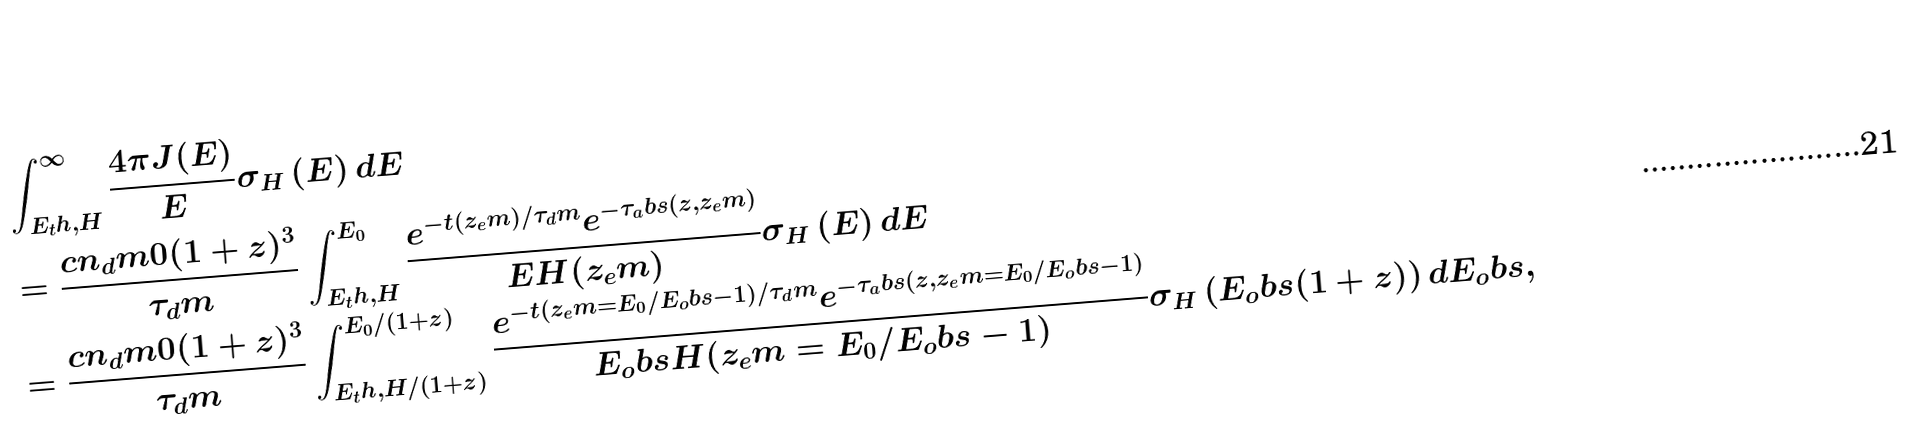<formula> <loc_0><loc_0><loc_500><loc_500>& \int ^ { \infty } _ { E _ { t } h , H } \frac { 4 \pi J ( E ) } { E } \sigma _ { H } \left ( E \right ) d E \\ & = \frac { c n _ { d } m 0 ( 1 + z ) ^ { 3 } } { \tau _ { d } m } \int ^ { E _ { 0 } } _ { E _ { t } h , H } \frac { e ^ { - t ( z _ { e } m ) / \tau _ { d } m } e ^ { - \tau _ { a } b s ( z , z _ { e } m ) } } { E H ( z _ { e } m ) } \sigma _ { H } \left ( E \right ) d E \\ & = \frac { c n _ { d } m 0 ( 1 + z ) ^ { 3 } } { \tau _ { d } m } \int ^ { E _ { 0 } / ( 1 + z ) } _ { E _ { t } h , H / ( 1 + z ) } \frac { e ^ { - t ( z _ { e } m = E _ { 0 } / E _ { o } b s - 1 ) / \tau _ { d } m } e ^ { - \tau _ { a } b s ( z , z _ { e } m = E _ { 0 } / E _ { o } b s - 1 ) } } { E _ { o } b s H ( z _ { e } m = E _ { 0 } / E _ { o } b s - 1 ) } \sigma _ { H } \left ( E _ { o } b s ( 1 + z ) \right ) d E _ { o } b s ,</formula> 